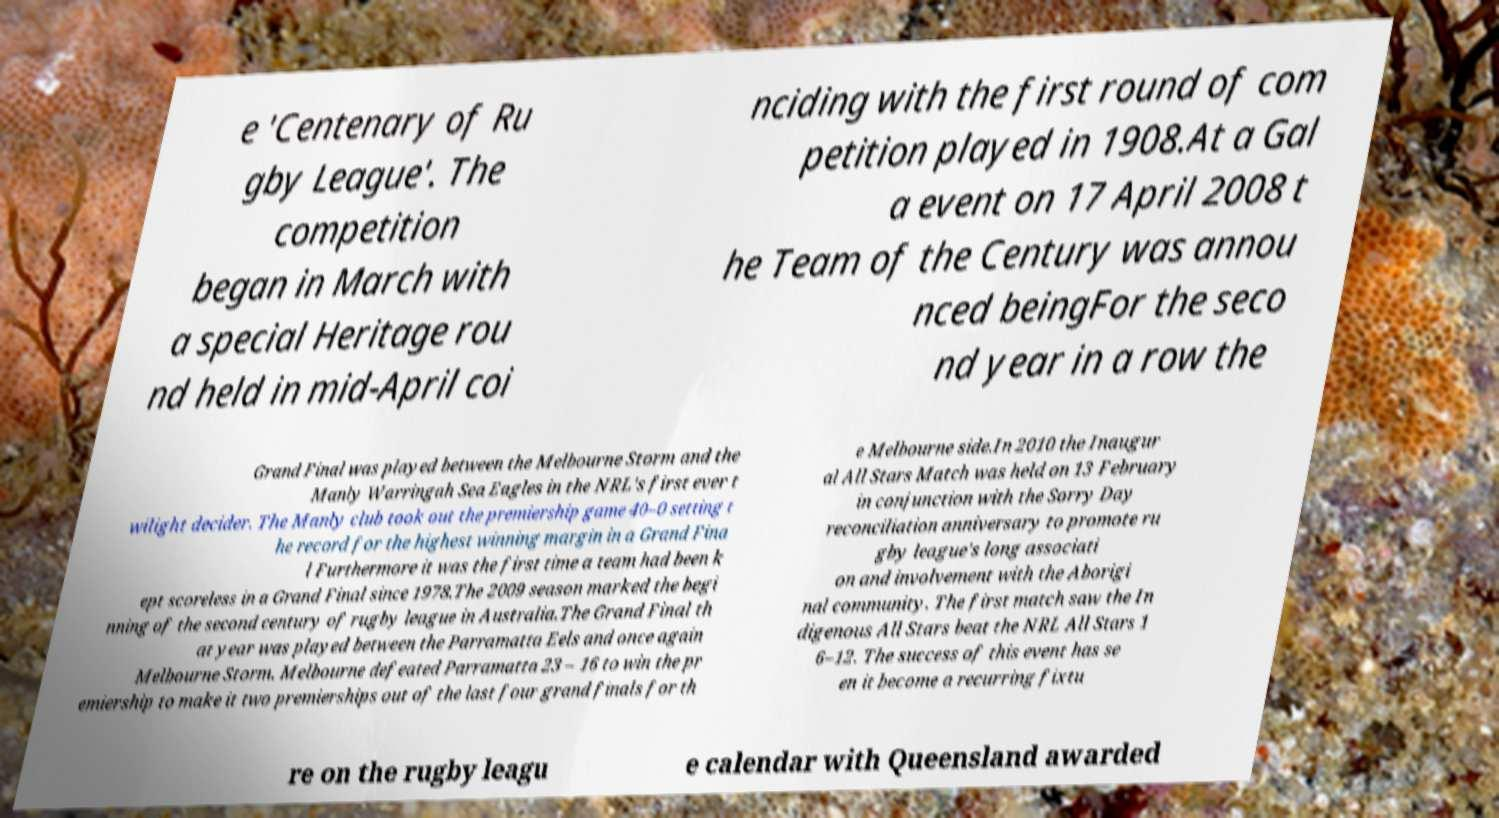Could you assist in decoding the text presented in this image and type it out clearly? e 'Centenary of Ru gby League'. The competition began in March with a special Heritage rou nd held in mid-April coi nciding with the first round of com petition played in 1908.At a Gal a event on 17 April 2008 t he Team of the Century was annou nced beingFor the seco nd year in a row the Grand Final was played between the Melbourne Storm and the Manly Warringah Sea Eagles in the NRL's first ever t wilight decider. The Manly club took out the premiership game 40–0 setting t he record for the highest winning margin in a Grand Fina l Furthermore it was the first time a team had been k ept scoreless in a Grand Final since 1978.The 2009 season marked the begi nning of the second century of rugby league in Australia.The Grand Final th at year was played between the Parramatta Eels and once again Melbourne Storm. Melbourne defeated Parramatta 23 – 16 to win the pr emiership to make it two premierships out of the last four grand finals for th e Melbourne side.In 2010 the Inaugur al All Stars Match was held on 13 February in conjunction with the Sorry Day reconciliation anniversary to promote ru gby league's long associati on and involvement with the Aborigi nal community. The first match saw the In digenous All Stars beat the NRL All Stars 1 6–12. The success of this event has se en it become a recurring fixtu re on the rugby leagu e calendar with Queensland awarded 